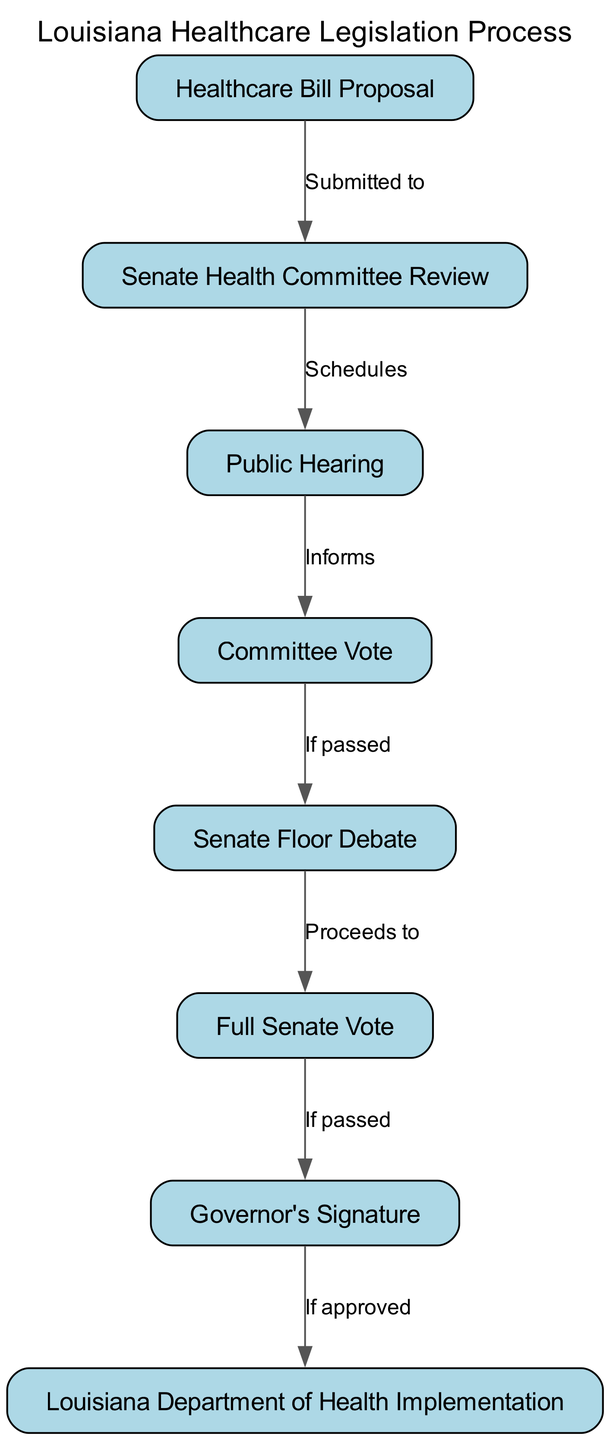What is the first step in the healthcare legislation process? The first step in the process according to the diagram is "Healthcare Bill Proposal," which is where the process begins.
Answer: Healthcare Bill Proposal How many nodes are in the diagram? By counting all the nodes listed in the diagram, there are a total of 8 nodes representing various stages in the healthcare legislation process.
Answer: 8 What happens after the Senate Health Committee Review? Following the Senate Health Committee Review, the next step is a "Public Hearing," which is scheduled to inform the public and gather input.
Answer: Public Hearing What is required for a bill to proceed from the Committee Vote to the Senate Floor Debate? A bill must be "If passed" from the Committee Vote before it can proceed to the Senate Floor Debate, indicating that it needs to be approved by the committee.
Answer: If passed Which node represents the final step before implementation? The final step before implementation is represented by the "Louisiana Department of Health Implementation" node, which is the last stage in the legislation process after all approvals.
Answer: Louisiana Department of Health Implementation What is the relationship between the Full Senate Vote and the Governor's Signature? The relationship is that the Full Senate Vote must be "If passed" for it to move on to the Governor's Signature stage, indicating that legislative approval is necessary before it reaches the governor.
Answer: If passed What step follows the Public Hearing? After the Public Hearing, the next step in the process is the "Committee Vote," which follows the hearing to determine if the bill will progress further.
Answer: Committee Vote What action takes place after the Governor's Signature? After receiving the Governor's Signature, the action that takes place is the "Louisiana Department of Health Implementation," marking the transition from legislation to active healthcare policy.
Answer: Louisiana Department of Health Implementation 